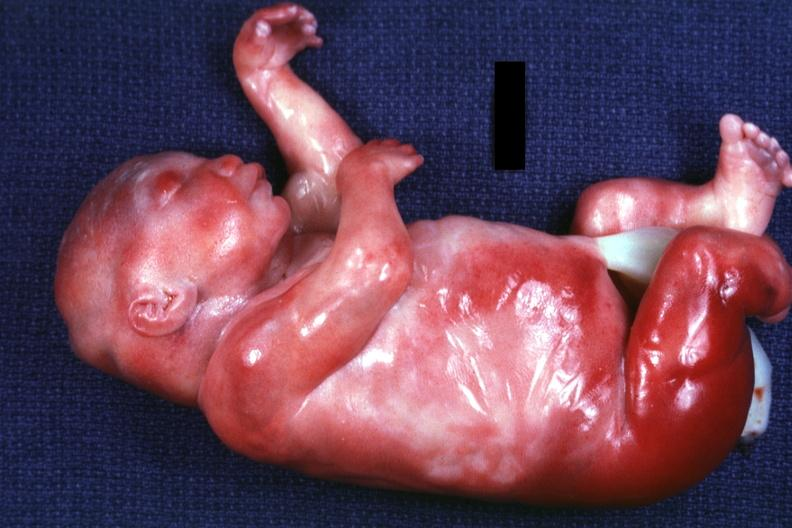what has six digits?
Answer the question using a single word or phrase. Lateral view of body with renal facies no neck and a barely seen vascular mass extruding from occipital region of skull arms and legs appear too short 